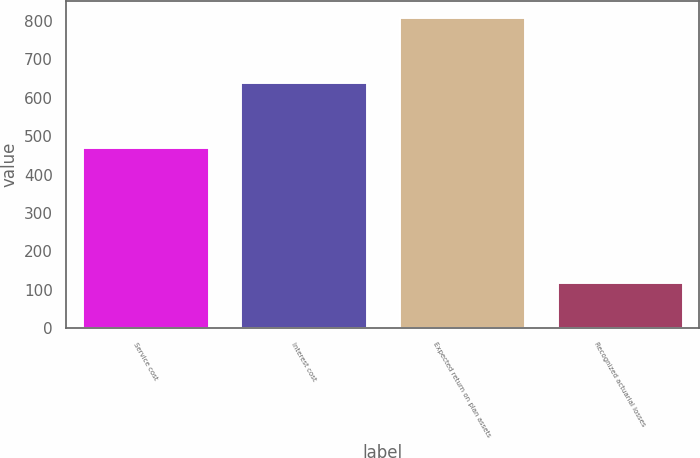<chart> <loc_0><loc_0><loc_500><loc_500><bar_chart><fcel>Service cost<fcel>Interest cost<fcel>Expected return on plan assets<fcel>Recognized actuarial losses<nl><fcel>473<fcel>642<fcel>811<fcel>121<nl></chart> 